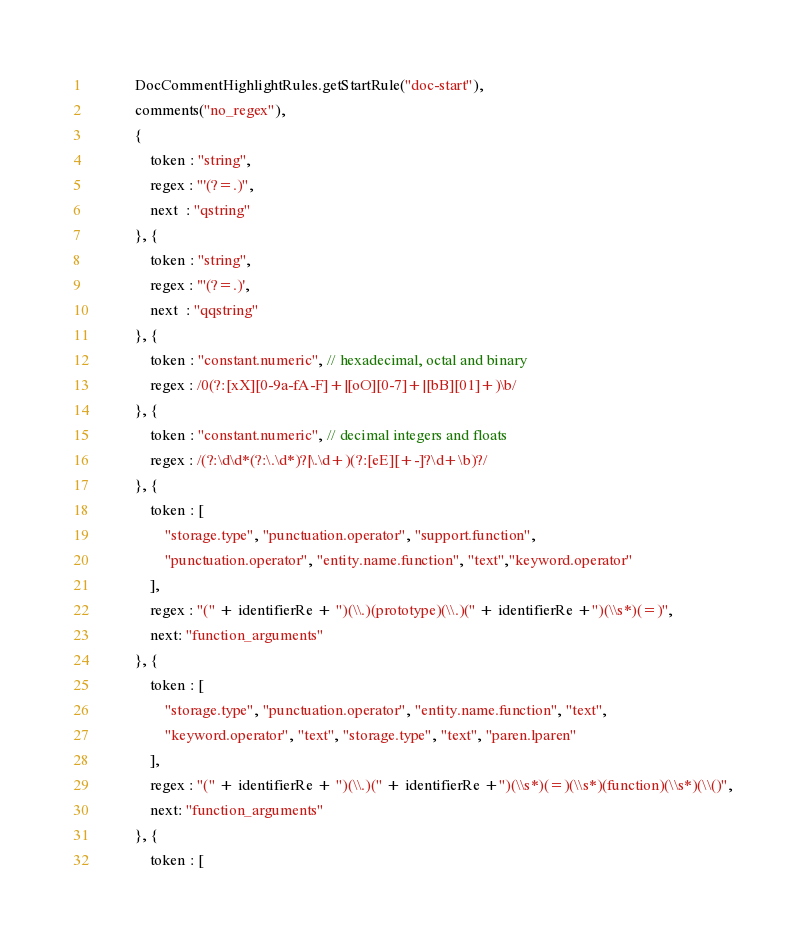Convert code to text. <code><loc_0><loc_0><loc_500><loc_500><_JavaScript_>            DocCommentHighlightRules.getStartRule("doc-start"),
            comments("no_regex"),
            {
                token : "string",
                regex : "'(?=.)",
                next  : "qstring"
            }, {
                token : "string",
                regex : '"(?=.)',
                next  : "qqstring"
            }, {
                token : "constant.numeric", // hexadecimal, octal and binary
                regex : /0(?:[xX][0-9a-fA-F]+|[oO][0-7]+|[bB][01]+)\b/
            }, {
                token : "constant.numeric", // decimal integers and floats
                regex : /(?:\d\d*(?:\.\d*)?|\.\d+)(?:[eE][+-]?\d+\b)?/
            }, {
                token : [
                    "storage.type", "punctuation.operator", "support.function",
                    "punctuation.operator", "entity.name.function", "text","keyword.operator"
                ],
                regex : "(" + identifierRe + ")(\\.)(prototype)(\\.)(" + identifierRe +")(\\s*)(=)",
                next: "function_arguments"
            }, {
                token : [
                    "storage.type", "punctuation.operator", "entity.name.function", "text",
                    "keyword.operator", "text", "storage.type", "text", "paren.lparen"
                ],
                regex : "(" + identifierRe + ")(\\.)(" + identifierRe +")(\\s*)(=)(\\s*)(function)(\\s*)(\\()",
                next: "function_arguments"
            }, {
                token : [</code> 